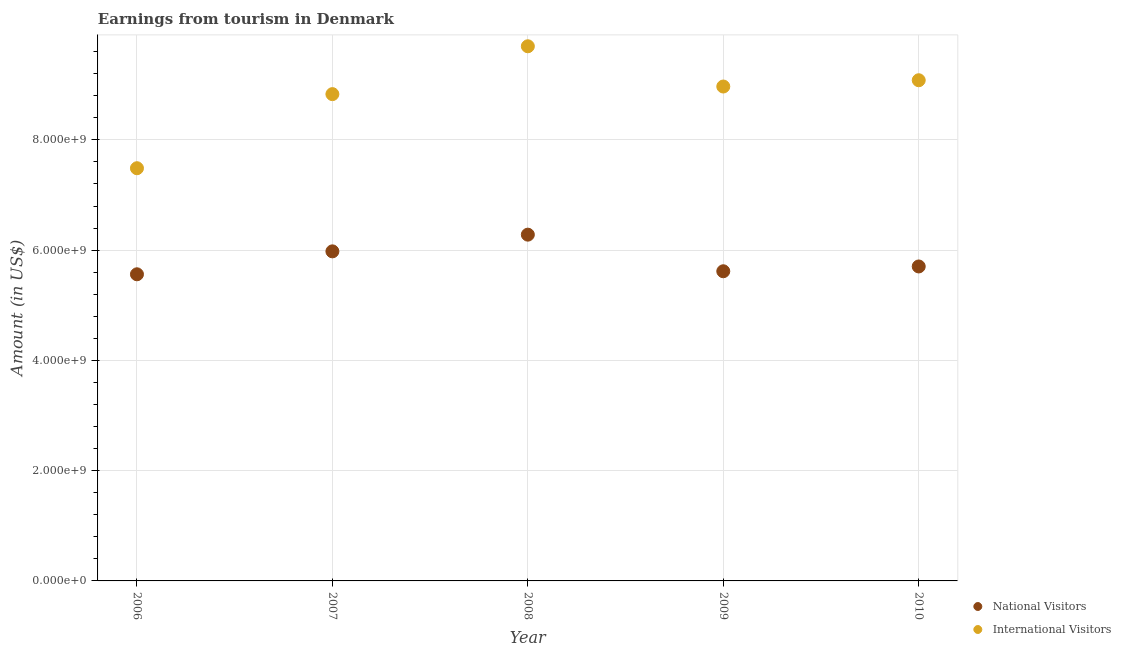Is the number of dotlines equal to the number of legend labels?
Offer a terse response. Yes. What is the amount earned from international visitors in 2009?
Provide a short and direct response. 8.97e+09. Across all years, what is the maximum amount earned from international visitors?
Offer a very short reply. 9.70e+09. Across all years, what is the minimum amount earned from national visitors?
Make the answer very short. 5.56e+09. What is the total amount earned from international visitors in the graph?
Ensure brevity in your answer.  4.41e+1. What is the difference between the amount earned from international visitors in 2006 and that in 2009?
Your answer should be compact. -1.48e+09. What is the difference between the amount earned from international visitors in 2010 and the amount earned from national visitors in 2008?
Give a very brief answer. 2.80e+09. What is the average amount earned from international visitors per year?
Your answer should be compact. 8.81e+09. In the year 2007, what is the difference between the amount earned from national visitors and amount earned from international visitors?
Your response must be concise. -2.85e+09. In how many years, is the amount earned from national visitors greater than 6800000000 US$?
Provide a succinct answer. 0. What is the ratio of the amount earned from national visitors in 2009 to that in 2010?
Make the answer very short. 0.98. What is the difference between the highest and the second highest amount earned from national visitors?
Your answer should be compact. 3.03e+08. What is the difference between the highest and the lowest amount earned from national visitors?
Provide a succinct answer. 7.19e+08. In how many years, is the amount earned from national visitors greater than the average amount earned from national visitors taken over all years?
Your response must be concise. 2. Does the amount earned from international visitors monotonically increase over the years?
Offer a terse response. No. Is the amount earned from international visitors strictly greater than the amount earned from national visitors over the years?
Offer a very short reply. Yes. How many dotlines are there?
Your answer should be very brief. 2. How are the legend labels stacked?
Provide a short and direct response. Vertical. What is the title of the graph?
Make the answer very short. Earnings from tourism in Denmark. What is the label or title of the Y-axis?
Give a very brief answer. Amount (in US$). What is the Amount (in US$) in National Visitors in 2006?
Offer a terse response. 5.56e+09. What is the Amount (in US$) in International Visitors in 2006?
Provide a succinct answer. 7.49e+09. What is the Amount (in US$) in National Visitors in 2007?
Your answer should be compact. 5.98e+09. What is the Amount (in US$) in International Visitors in 2007?
Your answer should be very brief. 8.83e+09. What is the Amount (in US$) of National Visitors in 2008?
Offer a very short reply. 6.28e+09. What is the Amount (in US$) in International Visitors in 2008?
Your response must be concise. 9.70e+09. What is the Amount (in US$) in National Visitors in 2009?
Give a very brief answer. 5.62e+09. What is the Amount (in US$) in International Visitors in 2009?
Your response must be concise. 8.97e+09. What is the Amount (in US$) of National Visitors in 2010?
Your answer should be compact. 5.70e+09. What is the Amount (in US$) of International Visitors in 2010?
Keep it short and to the point. 9.08e+09. Across all years, what is the maximum Amount (in US$) in National Visitors?
Ensure brevity in your answer.  6.28e+09. Across all years, what is the maximum Amount (in US$) of International Visitors?
Give a very brief answer. 9.70e+09. Across all years, what is the minimum Amount (in US$) of National Visitors?
Offer a very short reply. 5.56e+09. Across all years, what is the minimum Amount (in US$) in International Visitors?
Your answer should be very brief. 7.49e+09. What is the total Amount (in US$) in National Visitors in the graph?
Make the answer very short. 2.91e+1. What is the total Amount (in US$) in International Visitors in the graph?
Give a very brief answer. 4.41e+1. What is the difference between the Amount (in US$) in National Visitors in 2006 and that in 2007?
Your response must be concise. -4.16e+08. What is the difference between the Amount (in US$) of International Visitors in 2006 and that in 2007?
Offer a terse response. -1.34e+09. What is the difference between the Amount (in US$) in National Visitors in 2006 and that in 2008?
Your answer should be very brief. -7.19e+08. What is the difference between the Amount (in US$) in International Visitors in 2006 and that in 2008?
Offer a terse response. -2.21e+09. What is the difference between the Amount (in US$) of National Visitors in 2006 and that in 2009?
Provide a short and direct response. -5.50e+07. What is the difference between the Amount (in US$) in International Visitors in 2006 and that in 2009?
Your answer should be compact. -1.48e+09. What is the difference between the Amount (in US$) in National Visitors in 2006 and that in 2010?
Your answer should be very brief. -1.42e+08. What is the difference between the Amount (in US$) of International Visitors in 2006 and that in 2010?
Keep it short and to the point. -1.60e+09. What is the difference between the Amount (in US$) of National Visitors in 2007 and that in 2008?
Provide a succinct answer. -3.03e+08. What is the difference between the Amount (in US$) of International Visitors in 2007 and that in 2008?
Ensure brevity in your answer.  -8.68e+08. What is the difference between the Amount (in US$) in National Visitors in 2007 and that in 2009?
Keep it short and to the point. 3.61e+08. What is the difference between the Amount (in US$) in International Visitors in 2007 and that in 2009?
Keep it short and to the point. -1.38e+08. What is the difference between the Amount (in US$) of National Visitors in 2007 and that in 2010?
Provide a short and direct response. 2.74e+08. What is the difference between the Amount (in US$) of International Visitors in 2007 and that in 2010?
Your response must be concise. -2.52e+08. What is the difference between the Amount (in US$) in National Visitors in 2008 and that in 2009?
Give a very brief answer. 6.64e+08. What is the difference between the Amount (in US$) in International Visitors in 2008 and that in 2009?
Your answer should be compact. 7.30e+08. What is the difference between the Amount (in US$) of National Visitors in 2008 and that in 2010?
Your answer should be compact. 5.77e+08. What is the difference between the Amount (in US$) of International Visitors in 2008 and that in 2010?
Keep it short and to the point. 6.16e+08. What is the difference between the Amount (in US$) in National Visitors in 2009 and that in 2010?
Your answer should be very brief. -8.70e+07. What is the difference between the Amount (in US$) of International Visitors in 2009 and that in 2010?
Your answer should be very brief. -1.14e+08. What is the difference between the Amount (in US$) of National Visitors in 2006 and the Amount (in US$) of International Visitors in 2007?
Provide a succinct answer. -3.27e+09. What is the difference between the Amount (in US$) of National Visitors in 2006 and the Amount (in US$) of International Visitors in 2008?
Make the answer very short. -4.14e+09. What is the difference between the Amount (in US$) of National Visitors in 2006 and the Amount (in US$) of International Visitors in 2009?
Keep it short and to the point. -3.41e+09. What is the difference between the Amount (in US$) of National Visitors in 2006 and the Amount (in US$) of International Visitors in 2010?
Provide a short and direct response. -3.52e+09. What is the difference between the Amount (in US$) in National Visitors in 2007 and the Amount (in US$) in International Visitors in 2008?
Your response must be concise. -3.72e+09. What is the difference between the Amount (in US$) of National Visitors in 2007 and the Amount (in US$) of International Visitors in 2009?
Keep it short and to the point. -2.99e+09. What is the difference between the Amount (in US$) of National Visitors in 2007 and the Amount (in US$) of International Visitors in 2010?
Your answer should be very brief. -3.10e+09. What is the difference between the Amount (in US$) of National Visitors in 2008 and the Amount (in US$) of International Visitors in 2009?
Make the answer very short. -2.69e+09. What is the difference between the Amount (in US$) of National Visitors in 2008 and the Amount (in US$) of International Visitors in 2010?
Offer a very short reply. -2.80e+09. What is the difference between the Amount (in US$) in National Visitors in 2009 and the Amount (in US$) in International Visitors in 2010?
Give a very brief answer. -3.46e+09. What is the average Amount (in US$) of National Visitors per year?
Provide a succinct answer. 5.83e+09. What is the average Amount (in US$) of International Visitors per year?
Provide a short and direct response. 8.81e+09. In the year 2006, what is the difference between the Amount (in US$) of National Visitors and Amount (in US$) of International Visitors?
Make the answer very short. -1.92e+09. In the year 2007, what is the difference between the Amount (in US$) in National Visitors and Amount (in US$) in International Visitors?
Ensure brevity in your answer.  -2.85e+09. In the year 2008, what is the difference between the Amount (in US$) of National Visitors and Amount (in US$) of International Visitors?
Provide a short and direct response. -3.42e+09. In the year 2009, what is the difference between the Amount (in US$) in National Visitors and Amount (in US$) in International Visitors?
Offer a very short reply. -3.35e+09. In the year 2010, what is the difference between the Amount (in US$) of National Visitors and Amount (in US$) of International Visitors?
Provide a succinct answer. -3.38e+09. What is the ratio of the Amount (in US$) of National Visitors in 2006 to that in 2007?
Keep it short and to the point. 0.93. What is the ratio of the Amount (in US$) of International Visitors in 2006 to that in 2007?
Give a very brief answer. 0.85. What is the ratio of the Amount (in US$) of National Visitors in 2006 to that in 2008?
Offer a very short reply. 0.89. What is the ratio of the Amount (in US$) in International Visitors in 2006 to that in 2008?
Provide a short and direct response. 0.77. What is the ratio of the Amount (in US$) of National Visitors in 2006 to that in 2009?
Your response must be concise. 0.99. What is the ratio of the Amount (in US$) in International Visitors in 2006 to that in 2009?
Make the answer very short. 0.83. What is the ratio of the Amount (in US$) of National Visitors in 2006 to that in 2010?
Provide a succinct answer. 0.98. What is the ratio of the Amount (in US$) in International Visitors in 2006 to that in 2010?
Make the answer very short. 0.82. What is the ratio of the Amount (in US$) of National Visitors in 2007 to that in 2008?
Provide a short and direct response. 0.95. What is the ratio of the Amount (in US$) of International Visitors in 2007 to that in 2008?
Provide a succinct answer. 0.91. What is the ratio of the Amount (in US$) of National Visitors in 2007 to that in 2009?
Ensure brevity in your answer.  1.06. What is the ratio of the Amount (in US$) of International Visitors in 2007 to that in 2009?
Your answer should be very brief. 0.98. What is the ratio of the Amount (in US$) in National Visitors in 2007 to that in 2010?
Your response must be concise. 1.05. What is the ratio of the Amount (in US$) in International Visitors in 2007 to that in 2010?
Give a very brief answer. 0.97. What is the ratio of the Amount (in US$) in National Visitors in 2008 to that in 2009?
Your response must be concise. 1.12. What is the ratio of the Amount (in US$) of International Visitors in 2008 to that in 2009?
Keep it short and to the point. 1.08. What is the ratio of the Amount (in US$) in National Visitors in 2008 to that in 2010?
Ensure brevity in your answer.  1.1. What is the ratio of the Amount (in US$) of International Visitors in 2008 to that in 2010?
Ensure brevity in your answer.  1.07. What is the ratio of the Amount (in US$) in National Visitors in 2009 to that in 2010?
Ensure brevity in your answer.  0.98. What is the ratio of the Amount (in US$) of International Visitors in 2009 to that in 2010?
Make the answer very short. 0.99. What is the difference between the highest and the second highest Amount (in US$) of National Visitors?
Provide a short and direct response. 3.03e+08. What is the difference between the highest and the second highest Amount (in US$) in International Visitors?
Keep it short and to the point. 6.16e+08. What is the difference between the highest and the lowest Amount (in US$) in National Visitors?
Your response must be concise. 7.19e+08. What is the difference between the highest and the lowest Amount (in US$) of International Visitors?
Make the answer very short. 2.21e+09. 